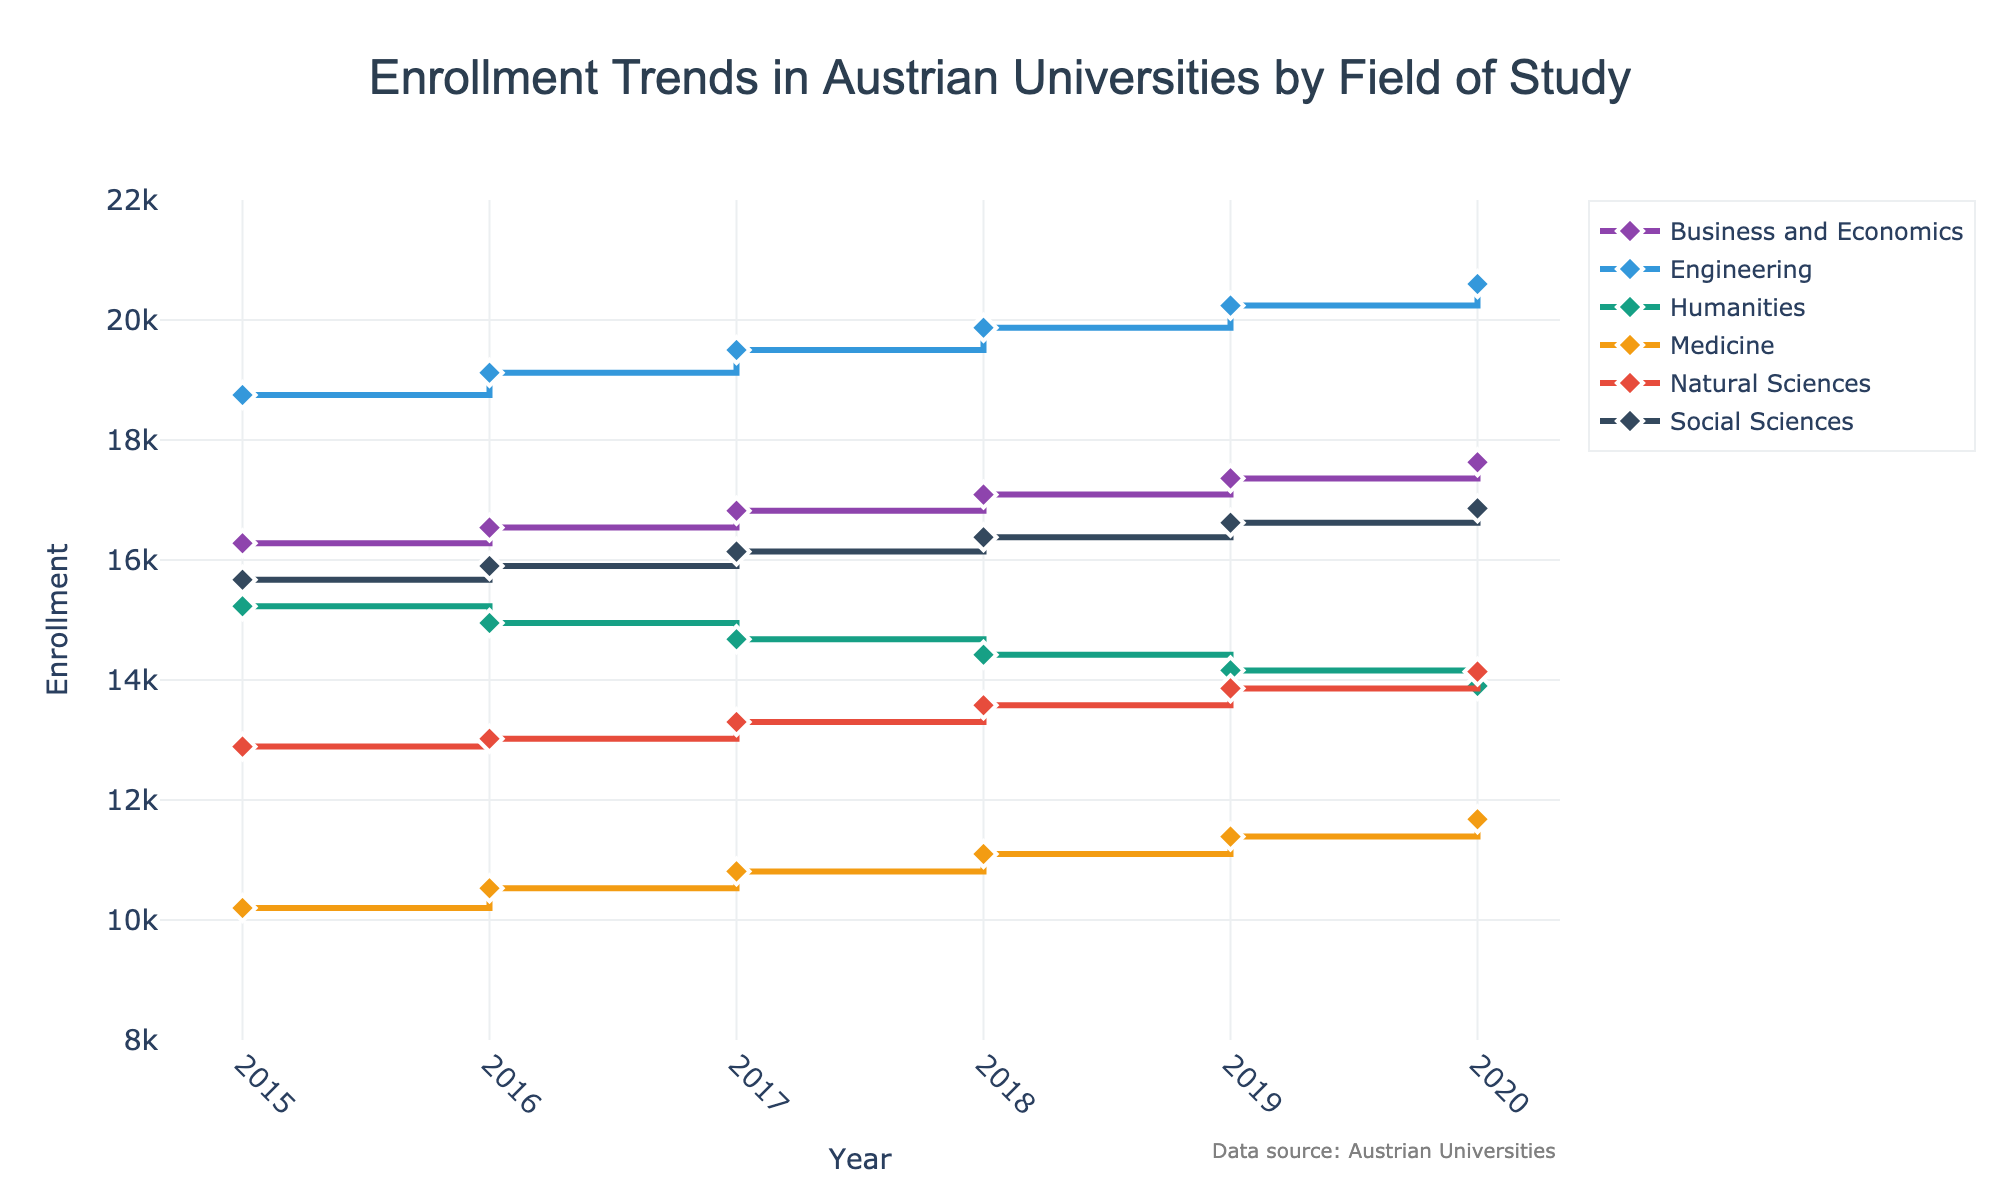what is the title of the figure? The title is located at the top center of the figure. Reading it can tell you what the graph is about.
Answer: Enrollment Trends in Austrian Universities by Field of Study how many fields of study are represented in the figure? Each field of study corresponds to a unique line in the stair plot. By counting the lines and their corresponding legend entries, you can determine the number.
Answer: 6 which year shows the highest enrollment in Engineering? Locate the line representing Engineering. Identify the data point with the highest y-value, and look at its corresponding x-value for the year.
Answer: 2020 what is the difference in enrollment between Social Sciences and Medicine in 2020? Find the enrollment values for both Social Sciences and Medicine in 2020. Calculate the difference by subtracting the enrollment of Medicine from Social Sciences.
Answer: 16860 - 11680 = 5180 between which years did Business and Economics see the largest increase in enrollment? Identify the Business and Economics line and examine the y-values. Determine the pair of consecutive years with the greatest positive change in y-value.
Answer: 2019 to 2020 which field of study had the most consistent increase in enrollment from 2015 to 2020? Look at the overall trend for each field of study's line. The field with a steady upward slope represents the most consistent increase.
Answer: Engineering in which year did Humanities enrollment drop below 15000? Trace the line for Humanities and identify the year when it first dips below the 15000 mark on the y-axis.
Answer: 2016 how did the enrollment in Natural Sciences change from 2017 to 2018? Identify the points for Natural Sciences in 2017 and 2018. Subtract the 2017 enrollment value from the 2018 value to find the change.
Answer: 13580 - 13300 = 280 which two fields of study had the highest and lowest enrollments in 2019? For 2019, compare the y-values of all lines. The highest y-value corresponds to the field with the highest enrollment, and the lowest y-value corresponds to the field with the lowest enrollment.
Answer: Engineering (highest) and Medicine (lowest) 